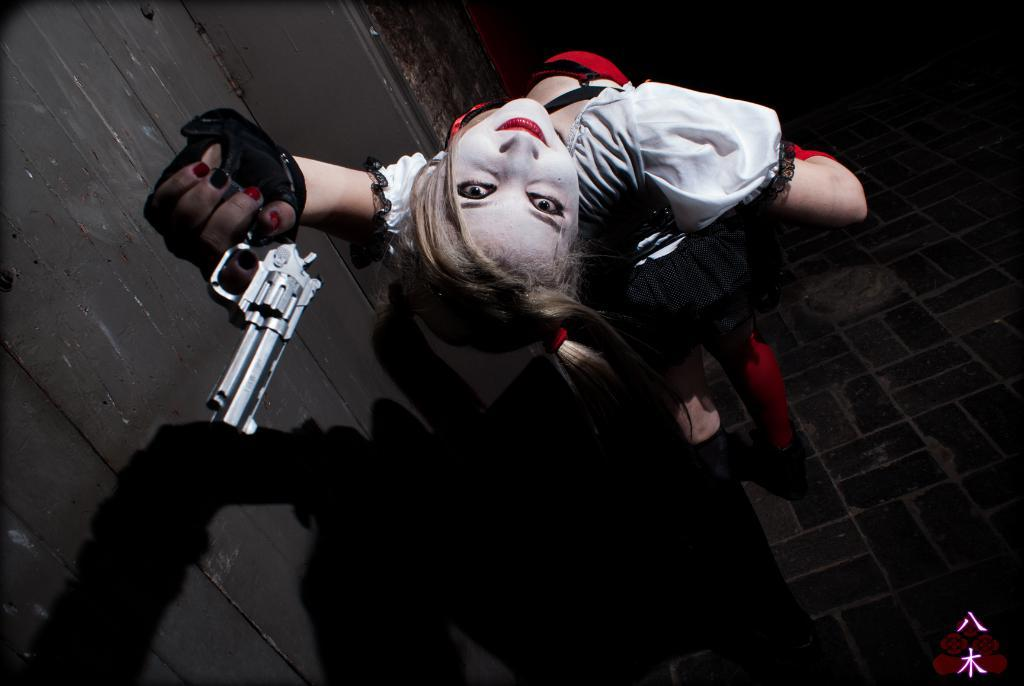Who is present in the image? There is a woman in the image. What is the woman doing in the image? The woman is standing in the image. What object is the woman holding? The woman is holding a gun in the image. What can be seen on the left side of the image? There is a wall on the left side of the image. How would you describe the overall lighting in the image? The background of the image is dark. Can you see any islands in the image? There are no islands present in the image. Is there a horse visible in the image? There is no horse present in the image. 